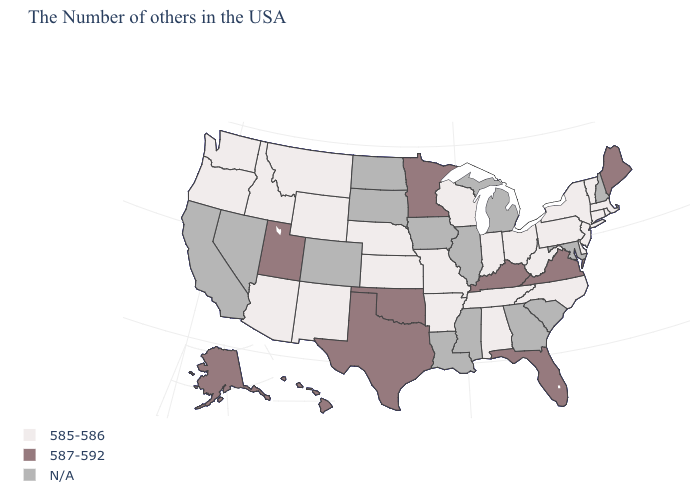What is the value of Maryland?
Concise answer only. N/A. What is the value of Nebraska?
Answer briefly. 585-586. What is the highest value in the USA?
Short answer required. 587-592. Name the states that have a value in the range N/A?
Answer briefly. New Hampshire, Maryland, South Carolina, Georgia, Michigan, Illinois, Mississippi, Louisiana, Iowa, South Dakota, North Dakota, Colorado, Nevada, California. What is the value of Massachusetts?
Quick response, please. 585-586. What is the value of Indiana?
Give a very brief answer. 585-586. What is the value of Minnesota?
Write a very short answer. 587-592. Does the first symbol in the legend represent the smallest category?
Write a very short answer. Yes. Name the states that have a value in the range 587-592?
Short answer required. Maine, Virginia, Florida, Kentucky, Minnesota, Oklahoma, Texas, Utah, Alaska, Hawaii. What is the highest value in the MidWest ?
Give a very brief answer. 587-592. Name the states that have a value in the range N/A?
Write a very short answer. New Hampshire, Maryland, South Carolina, Georgia, Michigan, Illinois, Mississippi, Louisiana, Iowa, South Dakota, North Dakota, Colorado, Nevada, California. How many symbols are there in the legend?
Keep it brief. 3. Name the states that have a value in the range 585-586?
Be succinct. Massachusetts, Rhode Island, Vermont, Connecticut, New York, New Jersey, Delaware, Pennsylvania, North Carolina, West Virginia, Ohio, Indiana, Alabama, Tennessee, Wisconsin, Missouri, Arkansas, Kansas, Nebraska, Wyoming, New Mexico, Montana, Arizona, Idaho, Washington, Oregon. What is the highest value in states that border Illinois?
Concise answer only. 587-592. Which states hav the highest value in the MidWest?
Answer briefly. Minnesota. 